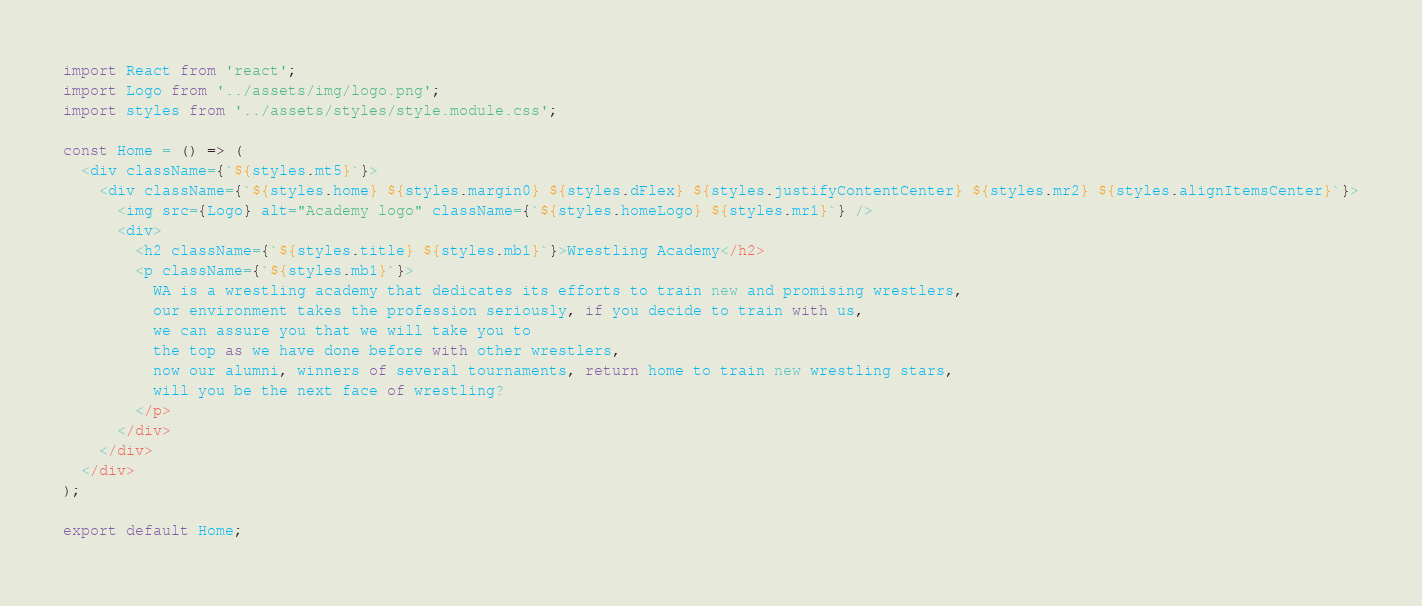<code> <loc_0><loc_0><loc_500><loc_500><_JavaScript_>import React from 'react';
import Logo from '../assets/img/logo.png';
import styles from '../assets/styles/style.module.css';

const Home = () => (
  <div className={`${styles.mt5}`}>
    <div className={`${styles.home} ${styles.margin0} ${styles.dFlex} ${styles.justifyContentCenter} ${styles.mr2} ${styles.alignItemsCenter}`}>
      <img src={Logo} alt="Academy logo" className={`${styles.homeLogo} ${styles.mr1}`} />
      <div>
        <h2 className={`${styles.title} ${styles.mb1}`}>Wrestling Academy</h2>
        <p className={`${styles.mb1}`}>
          WA is a wrestling academy that dedicates its efforts to train new and promising wrestlers,
          our environment takes the profession seriously, if you decide to train with us,
          we can assure you that we will take you to
          the top as we have done before with other wrestlers,
          now our alumni, winners of several tournaments, return home to train new wrestling stars,
          will you be the next face of wrestling?
        </p>
      </div>
    </div>
  </div>
);

export default Home;
</code> 